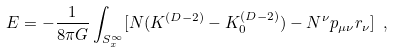Convert formula to latex. <formula><loc_0><loc_0><loc_500><loc_500>E = - \frac { 1 } { 8 \pi G } \int _ { S _ { x } ^ { \infty } } [ N ( K ^ { ( D - 2 ) } - K _ { 0 } ^ { ( D - 2 ) } ) - N ^ { \nu } p _ { \mu \nu } r _ { \nu } ] \ ,</formula> 